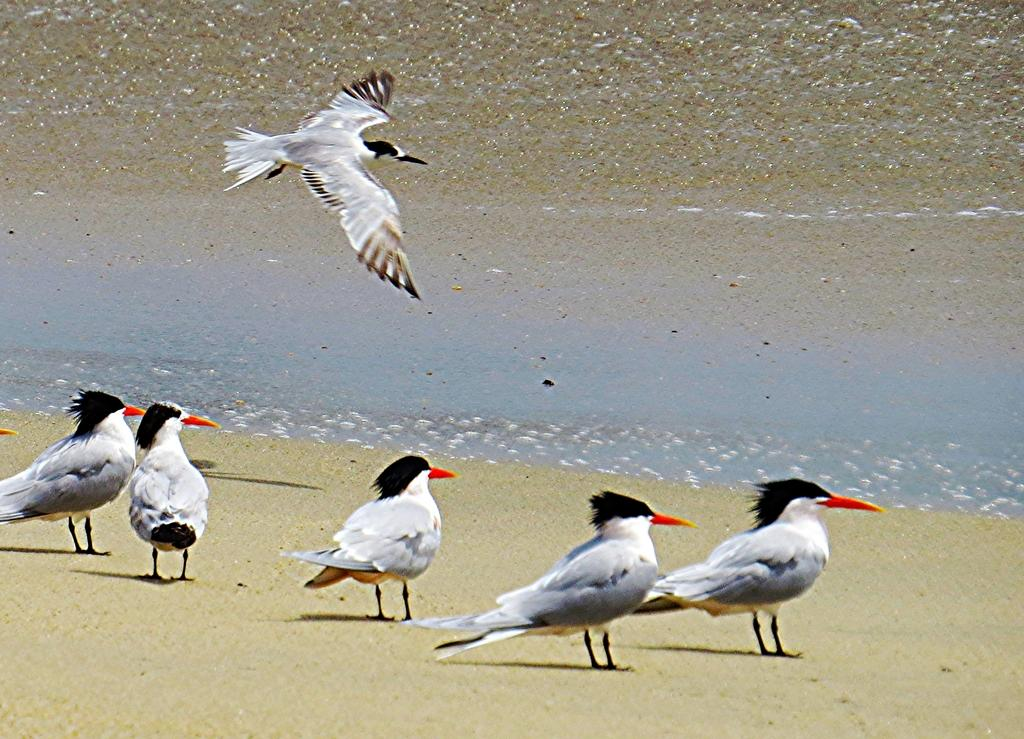What type of animals can be seen in the image? There is a group of birds in the image. What are the positions of the birds in the image? Some birds are standing on the ground, and one bird is flying in the air. What type of jar can be seen in the image? There is no jar present in the image; it features a group of birds. How many leaves are visible on the ground in the image? There is no mention of leaves in the image; it only features a group of birds. 